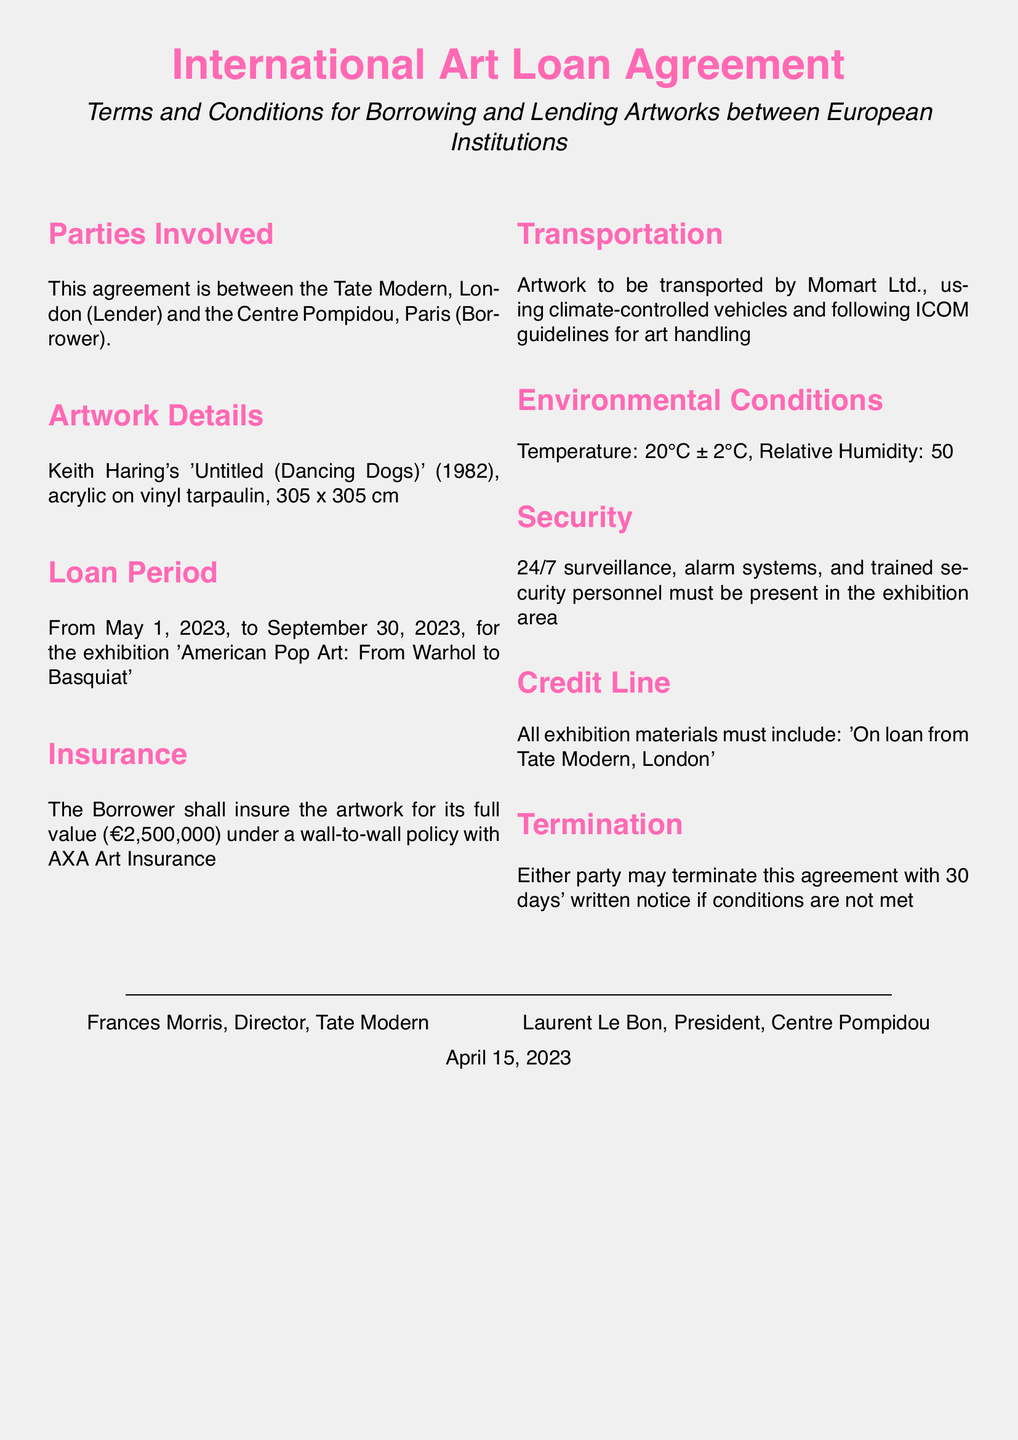What is the title of the artwork? The title is specified in the document under Artwork Details.
Answer: 'Untitled (Dancing Dogs)' What is the full value of the artwork? The full value for insurance purposes is provided in the Insurance section of the document.
Answer: €2,500,000 What is the loan period for the artwork? The dates for the loan period are listed in the Loan Period section of the document.
Answer: From May 1, 2023, to September 30, 2023 Who is responsible for transportation of the artwork? The transportation details are found in the Transportation section, specifying the company responsible.
Answer: Momart Ltd What environmental conditions are specified for the artwork? The document details specific conditions in the Environmental Conditions section.
Answer: Temperature: 20°C ± 2°C, Relative Humidity: 50% ± 5%, Light levels: Max 200 lux for 8 hours per day What must be included in the credit line for exhibition materials? The Credit Line section outlines what to include in exhibition materials.
Answer: 'On loan from Tate Modern, London' How many days' notice is required for termination of the agreement? The termination notice period is stated in the Termination section of the document.
Answer: 30 days Which insurance company is mentioned in the document? The Insurance section names the company providing the insurance policy.
Answer: AXA Art Insurance 